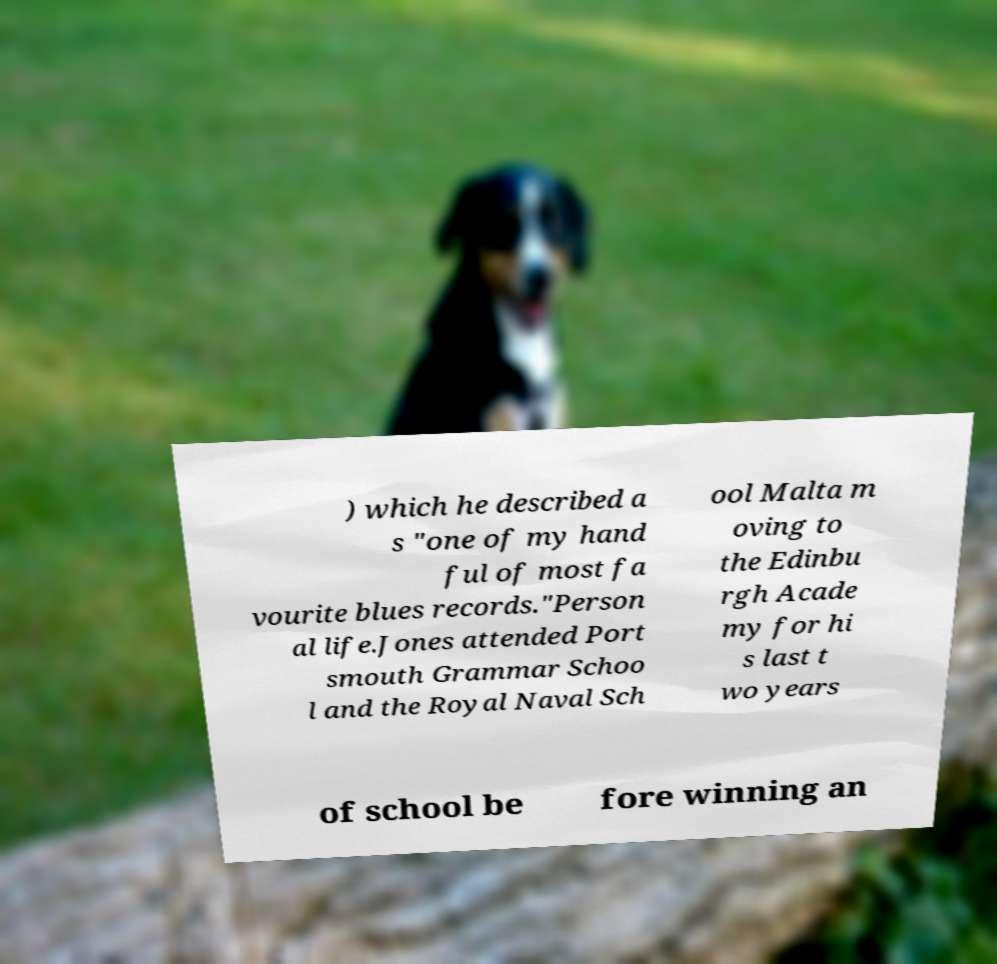Could you extract and type out the text from this image? ) which he described a s "one of my hand ful of most fa vourite blues records."Person al life.Jones attended Port smouth Grammar Schoo l and the Royal Naval Sch ool Malta m oving to the Edinbu rgh Acade my for hi s last t wo years of school be fore winning an 